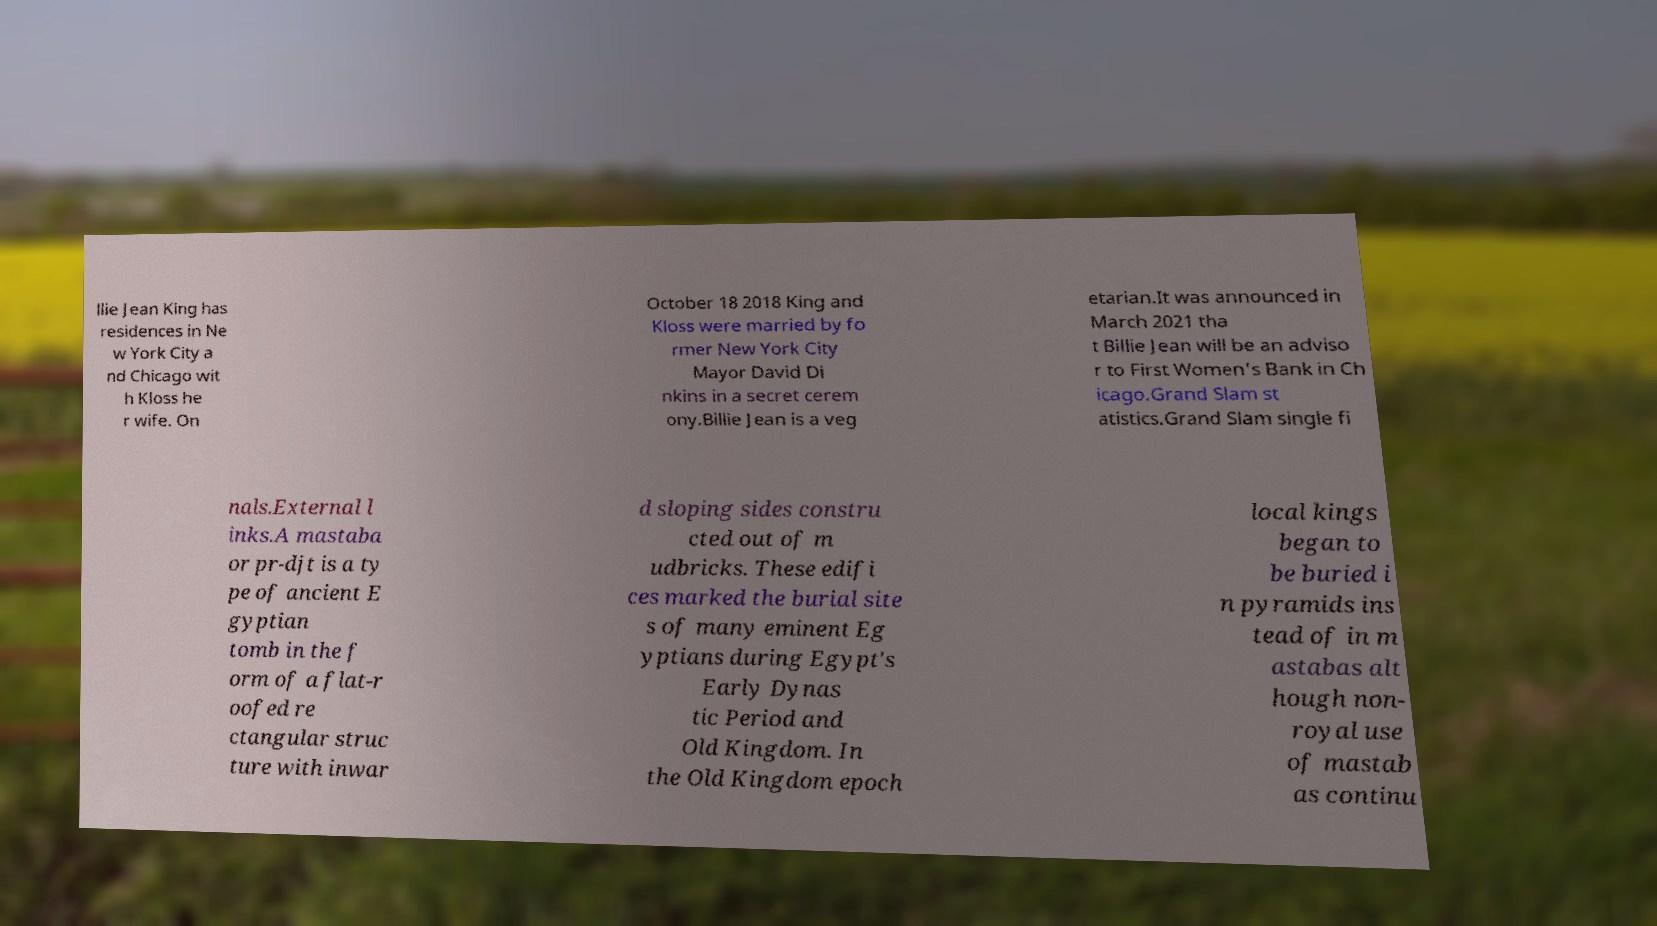I need the written content from this picture converted into text. Can you do that? llie Jean King has residences in Ne w York City a nd Chicago wit h Kloss he r wife. On October 18 2018 King and Kloss were married by fo rmer New York City Mayor David Di nkins in a secret cerem ony.Billie Jean is a veg etarian.It was announced in March 2021 tha t Billie Jean will be an adviso r to First Women's Bank in Ch icago.Grand Slam st atistics.Grand Slam single fi nals.External l inks.A mastaba or pr-djt is a ty pe of ancient E gyptian tomb in the f orm of a flat-r oofed re ctangular struc ture with inwar d sloping sides constru cted out of m udbricks. These edifi ces marked the burial site s of many eminent Eg yptians during Egypt's Early Dynas tic Period and Old Kingdom. In the Old Kingdom epoch local kings began to be buried i n pyramids ins tead of in m astabas alt hough non- royal use of mastab as continu 